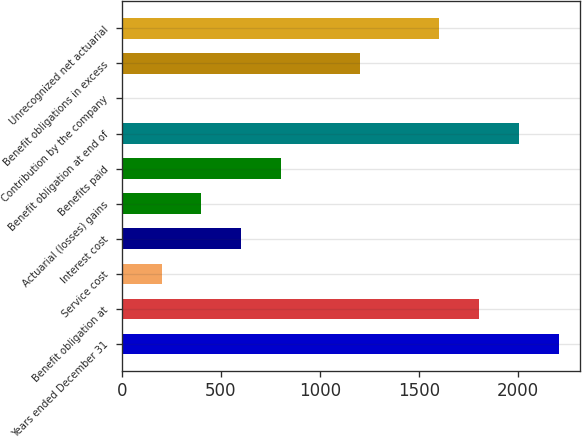Convert chart to OTSL. <chart><loc_0><loc_0><loc_500><loc_500><bar_chart><fcel>Years ended December 31<fcel>Benefit obligation at<fcel>Service cost<fcel>Interest cost<fcel>Actuarial (losses) gains<fcel>Benefits paid<fcel>Benefit obligation at end of<fcel>Contribution by the company<fcel>Benefit obligations in excess<fcel>Unrecognized net actuarial<nl><fcel>2204.38<fcel>1803.62<fcel>200.58<fcel>601.34<fcel>400.96<fcel>801.72<fcel>2004<fcel>0.2<fcel>1202.48<fcel>1603.24<nl></chart> 